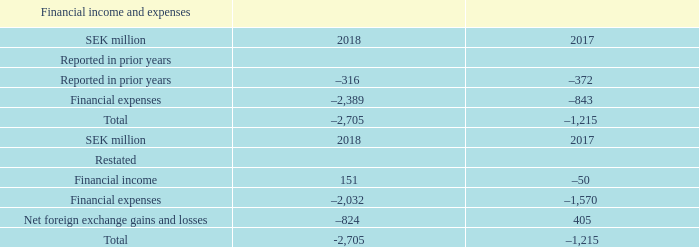Restatement – changes to the presentation of financial income and expenses
Due to the significant variations in SEK exchange rates during the year, the Company has considered the change in reporting of foreign exchange effect to reflect how foreign exchange transaction risk is managed on a net basis in the Company. Previously foreign exchange effects were reported within both financial income and financial expenses depending on whether they relate to assets or liabilities.
In note F2, “Financial income and expenses,” the foreign exchange effect is now presented as a net amount, reported separately from other financial income and expenses items. The comparative years 2018 and 2017 have been
restated to reflect the new presentation of Financial income and expenses, net. The restatement does not impact the total net financial income and expenses reported in prior years.
The following table shows the impact of the restatement:
In line with this change the Company also elected to present all financial income and expenses, including the foreign exchange effect, on the income statement as a single line item Financial income and expenses, net. Previously,
financial income and financial expenses were presented as separate line items on the income statement. The income statement for all comparative years 2018 and 2017 have been restated to reflect the new presentation of Financial
income and expenses, net.
What is the restated financial income in 2018?
Answer scale should be: million. 151. What is the restated total of financial income, expenses and net foreign exchange gains and losses in 2017?
Answer scale should be: million. –1,215. What is the restated total of financial income, expenses and net foreign exchange gains and losses in 2018?
Answer scale should be: million. -2,705. What is the change between the total of financial income, expenses and net foreign exchange gains and losses in 2018 and 2017?
Answer scale should be: million. -2,705-(-1,215)
Answer: -1490. What is the change in financial income between 2018 and 2017?
Answer scale should be: million. 151-(-50)
Answer: 201. What is the change in the net foreign exchange gains and losses between 2018 and 2017?
Answer scale should be: million. -824-405
Answer: -1229. 